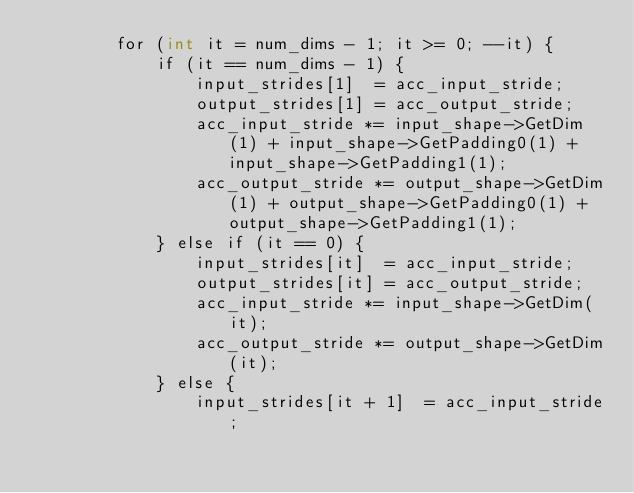Convert code to text. <code><loc_0><loc_0><loc_500><loc_500><_Cuda_>        for (int it = num_dims - 1; it >= 0; --it) {
            if (it == num_dims - 1) {
                input_strides[1]  = acc_input_stride;
                output_strides[1] = acc_output_stride;
                acc_input_stride *= input_shape->GetDim(1) + input_shape->GetPadding0(1) + input_shape->GetPadding1(1);
                acc_output_stride *= output_shape->GetDim(1) + output_shape->GetPadding0(1) + output_shape->GetPadding1(1);
            } else if (it == 0) {
                input_strides[it]  = acc_input_stride;
                output_strides[it] = acc_output_stride;
                acc_input_stride *= input_shape->GetDim(it);
                acc_output_stride *= output_shape->GetDim(it);
            } else {
                input_strides[it + 1]  = acc_input_stride;</code> 